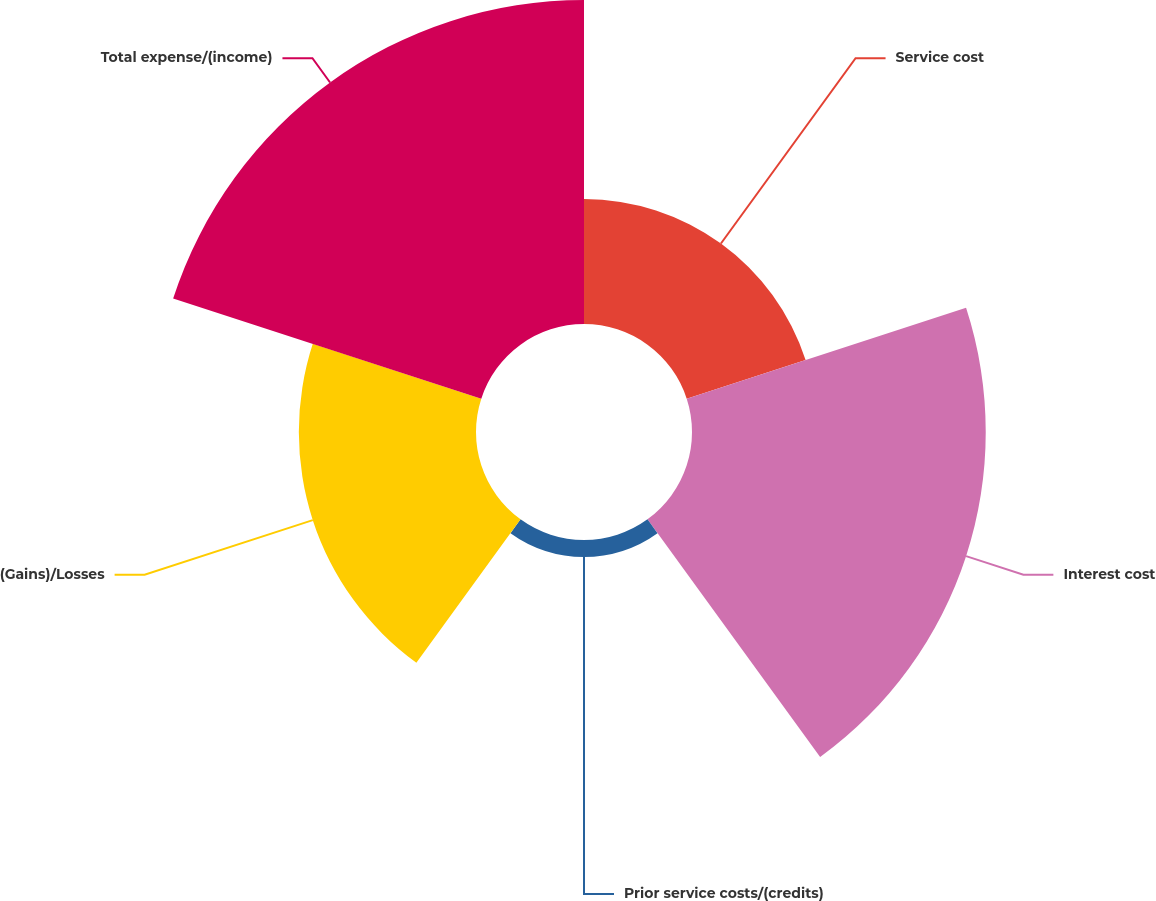Convert chart. <chart><loc_0><loc_0><loc_500><loc_500><pie_chart><fcel>Service cost<fcel>Interest cost<fcel>Prior service costs/(credits)<fcel>(Gains)/Losses<fcel>Total expense/(income)<nl><fcel>13.34%<fcel>31.35%<fcel>1.82%<fcel>18.91%<fcel>34.58%<nl></chart> 